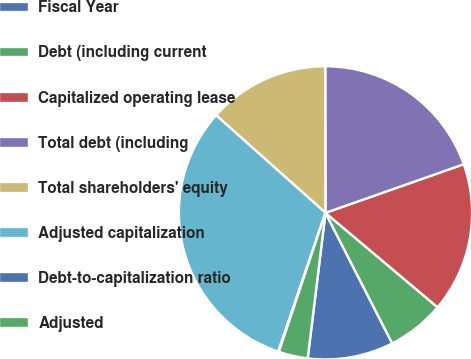Convert chart. <chart><loc_0><loc_0><loc_500><loc_500><pie_chart><fcel>Fiscal Year<fcel>Debt (including current<fcel>Capitalized operating lease<fcel>Total debt (including<fcel>Total shareholders' equity<fcel>Adjusted capitalization<fcel>Debt-to-capitalization ratio<fcel>Adjusted<nl><fcel>9.46%<fcel>6.34%<fcel>16.52%<fcel>19.64%<fcel>13.39%<fcel>31.37%<fcel>0.08%<fcel>3.21%<nl></chart> 